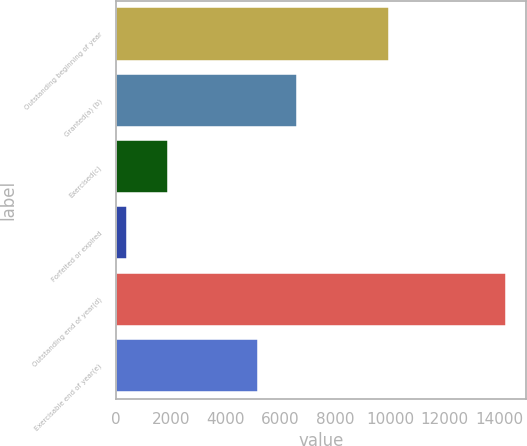Convert chart to OTSL. <chart><loc_0><loc_0><loc_500><loc_500><bar_chart><fcel>Outstanding beginning of year<fcel>Granted(a) (b)<fcel>Exercised(c)<fcel>Forfeited or expired<fcel>Outstanding end of year(d)<fcel>Exercisable end of year(e)<nl><fcel>9957<fcel>6597<fcel>1900<fcel>399<fcel>14255<fcel>5176<nl></chart> 